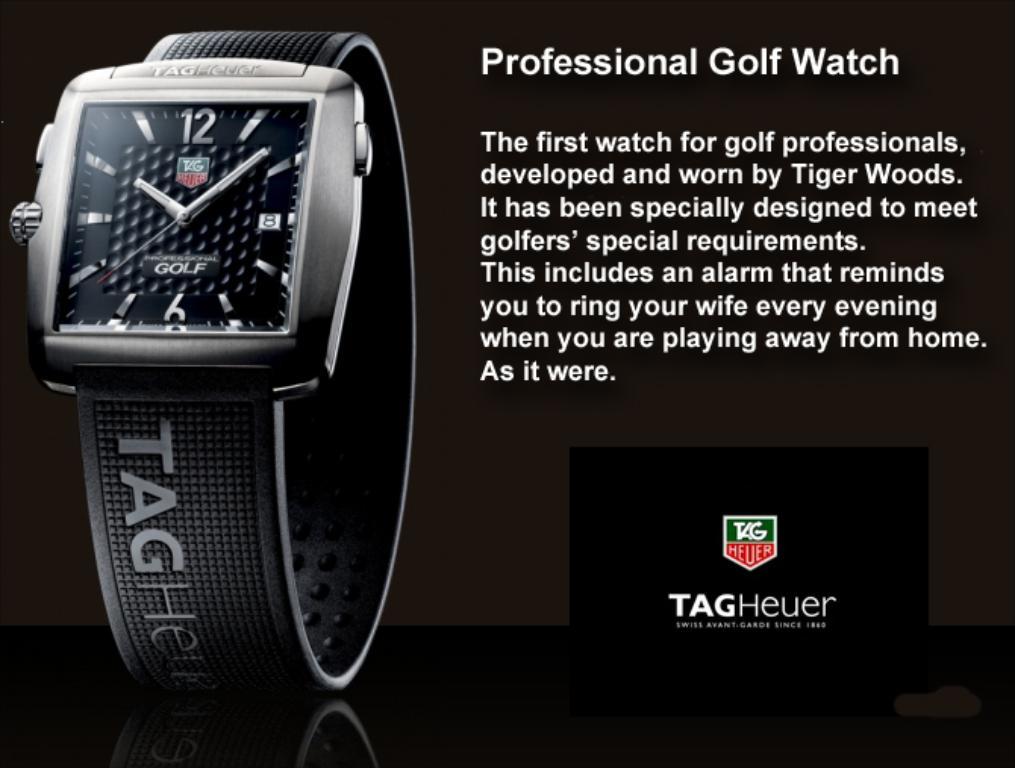What kind of watch is this?
Your answer should be very brief. Tag heuer. What is the brand of this watch?
Your answer should be compact. Tagheuer. 